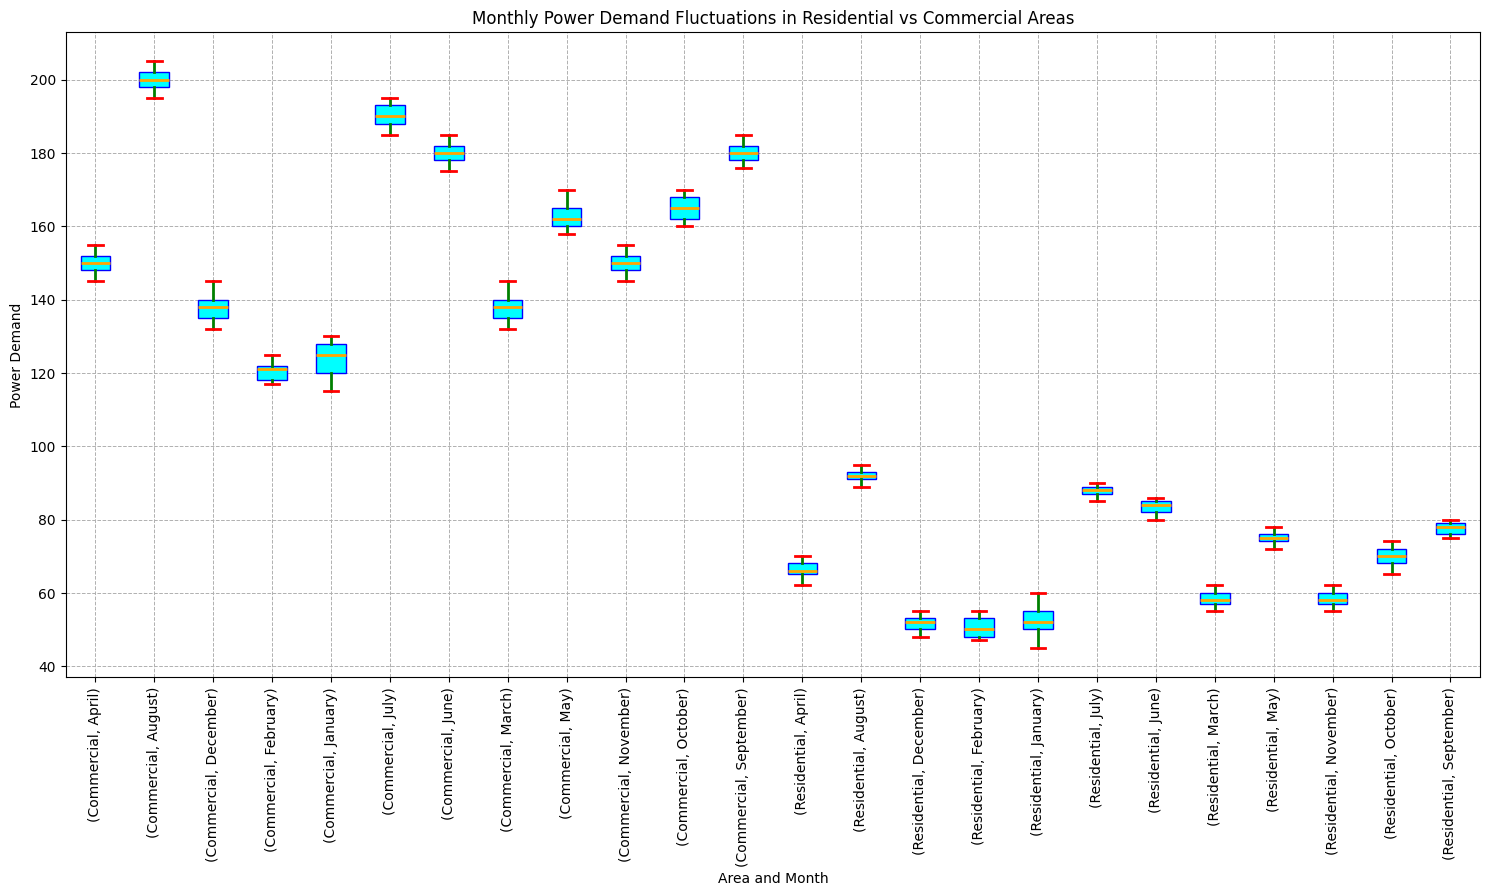What is the median power demand for residential areas in July? First, locate the box plot corresponding to the residential area for the month of July. The median is represented by the line inside the box.
Answer: 88 Which type of area shows higher median power demand in April? Compare the medians of the box plots for April for both residential and commercial areas. The commercial area has a higher median value.
Answer: Commercial Which month shows the greatest variation in power demand for commercial areas? The variation in a box plot is indicated by the length of the whiskers. Identify the month with the longest whiskers in the commercial area.
Answer: April What is the interquartile range (IQR) for residential power demand in January? Find the edges of the box for the residential area in January, which represents the 1st and 3rd quartiles (Q1 and Q3). The IQR is Q3 - Q1.
Answer: 10 Compare the median power demand of residential areas in December to commercial areas in December. Which is higher? Locate the medians for both areas in December and compare them visually. The commercial area has the higher median.
Answer: Commercial Is there any month where the residential area's power demand is higher than the commercial area's power demand? Across all months, compare the medians of residential and commercial areas. None of the residential medians surpass the commercial medians.
Answer: No What is the power demand range (minimum and maximum) observed in residential areas in August? Identify the whiskers (extremes) of the box plot for August in the residential area. This represents the range.
Answer: 89 to 95 How does the median power demand in commercial areas change from July to August? Observe the medians for the commercial area in July and August. Note the increase or decrease between the two medians.
Answer: Increase What is the median power demand difference between residential areas and commercial areas in May? Find the medians for both areas in May and subtract the residential median from the commercial median.
Answer: 87 Is the power demand in residential areas more consistent in summer (June-August) or winter (December-February)? Consistency is shown by smaller IQRs and shorter whiskers. Compare these visual attributes for summer and winter months in residential areas.
Answer: Winter 